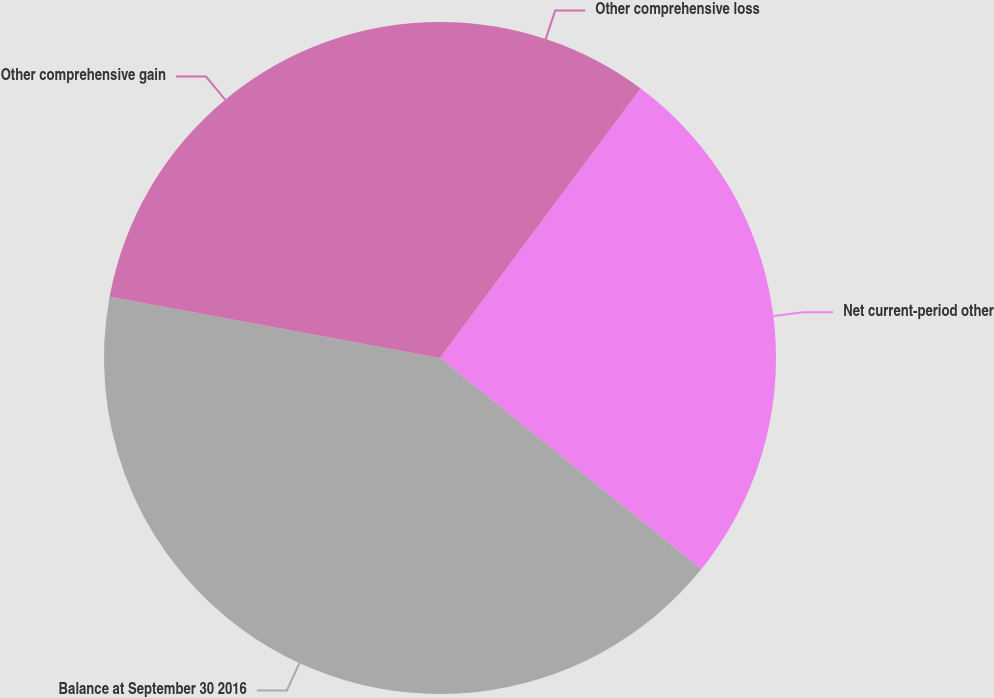Convert chart. <chart><loc_0><loc_0><loc_500><loc_500><pie_chart><fcel>Other comprehensive loss<fcel>Net current-period other<fcel>Balance at September 30 2016<fcel>Other comprehensive gain<nl><fcel>10.19%<fcel>25.63%<fcel>42.1%<fcel>22.08%<nl></chart> 